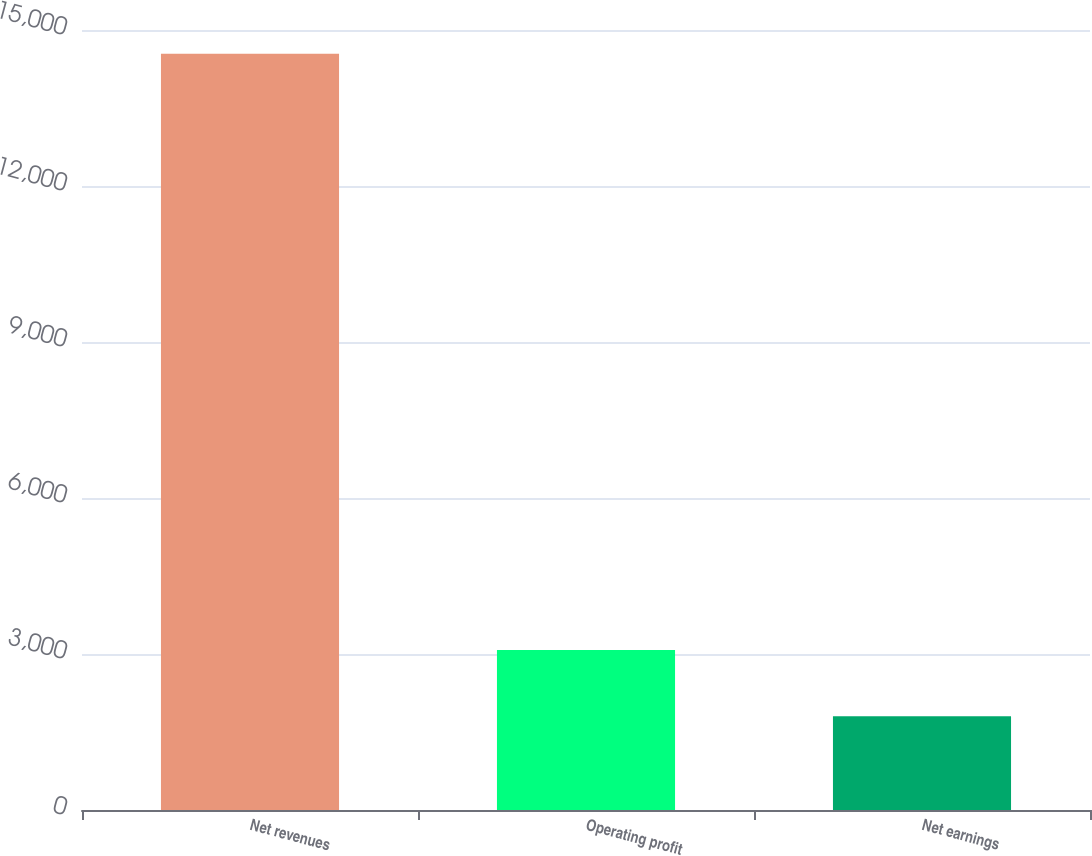Convert chart to OTSL. <chart><loc_0><loc_0><loc_500><loc_500><bar_chart><fcel>Net revenues<fcel>Operating profit<fcel>Net earnings<nl><fcel>14543<fcel>3077<fcel>1803<nl></chart> 